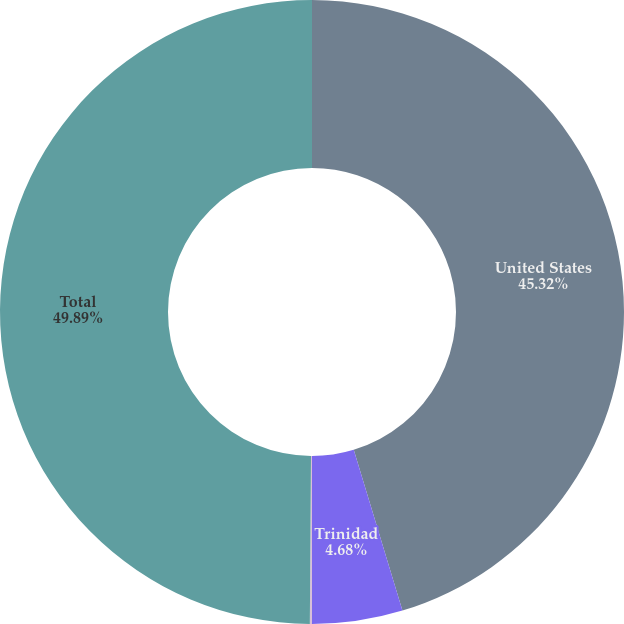Convert chart to OTSL. <chart><loc_0><loc_0><loc_500><loc_500><pie_chart><fcel>United States<fcel>Trinidad<fcel>Canada<fcel>Total<nl><fcel>45.32%<fcel>4.68%<fcel>0.11%<fcel>49.89%<nl></chart> 